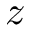Convert formula to latex. <formula><loc_0><loc_0><loc_500><loc_500>z</formula> 